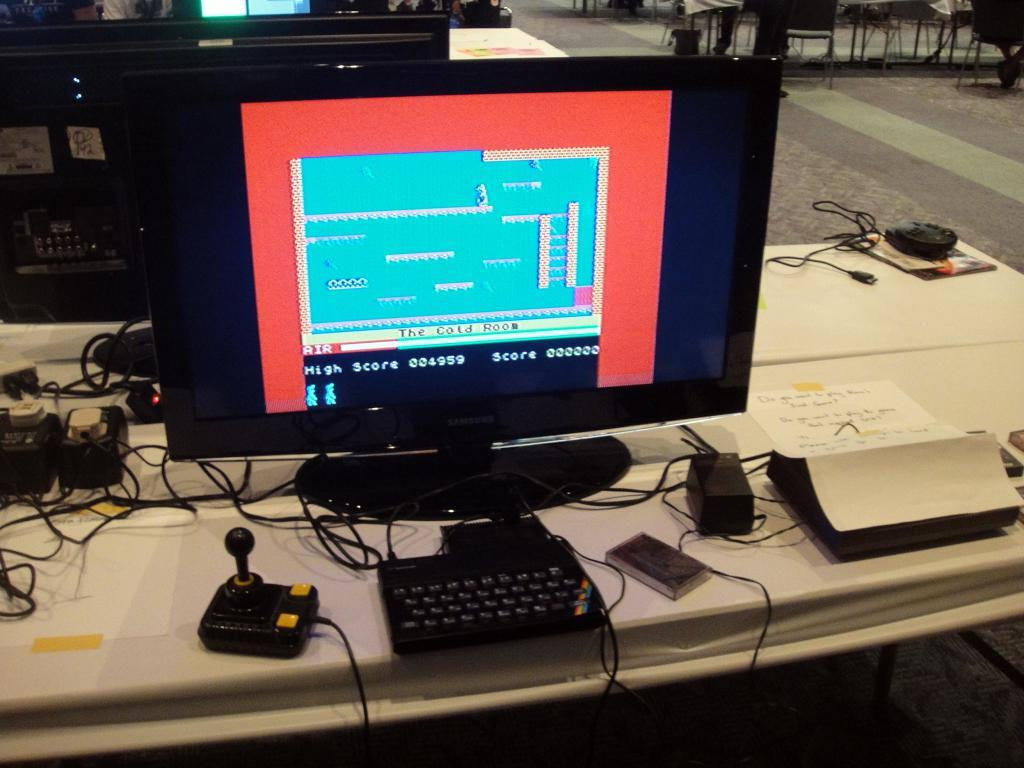<image>
Present a compact description of the photo's key features. A computer monitor shows an old game called "The cold room." 